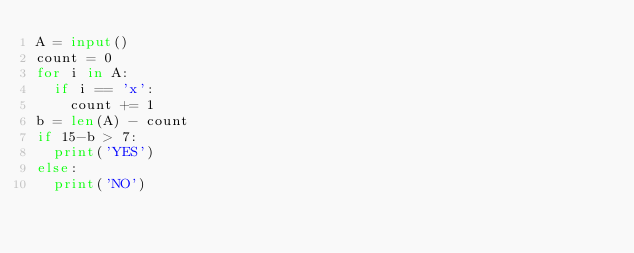<code> <loc_0><loc_0><loc_500><loc_500><_Python_>A = input()
count = 0
for i in A:
  if i == 'x':
    count += 1
b = len(A) - count
if 15-b > 7:
  print('YES')
else:
  print('NO')</code> 